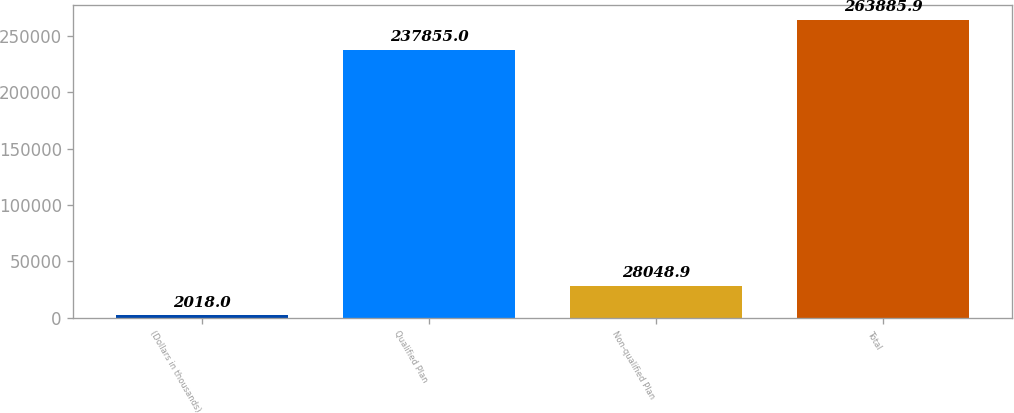<chart> <loc_0><loc_0><loc_500><loc_500><bar_chart><fcel>(Dollars in thousands)<fcel>Qualified Plan<fcel>Non-qualified Plan<fcel>Total<nl><fcel>2018<fcel>237855<fcel>28048.9<fcel>263886<nl></chart> 